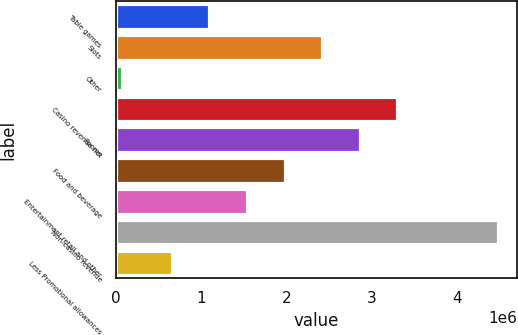<chart> <loc_0><loc_0><loc_500><loc_500><bar_chart><fcel>Table games<fcel>Slots<fcel>Other<fcel>Casino revenue net<fcel>Rooms<fcel>Food and beverage<fcel>Entertainment retail and other<fcel>Non-casino revenue<fcel>Less Promotional allowances<nl><fcel>1.09562e+06<fcel>2.41898e+06<fcel>70148<fcel>3.30123e+06<fcel>2.86011e+06<fcel>1.97786e+06<fcel>1.53674e+06<fcel>4.48136e+06<fcel>654498<nl></chart> 